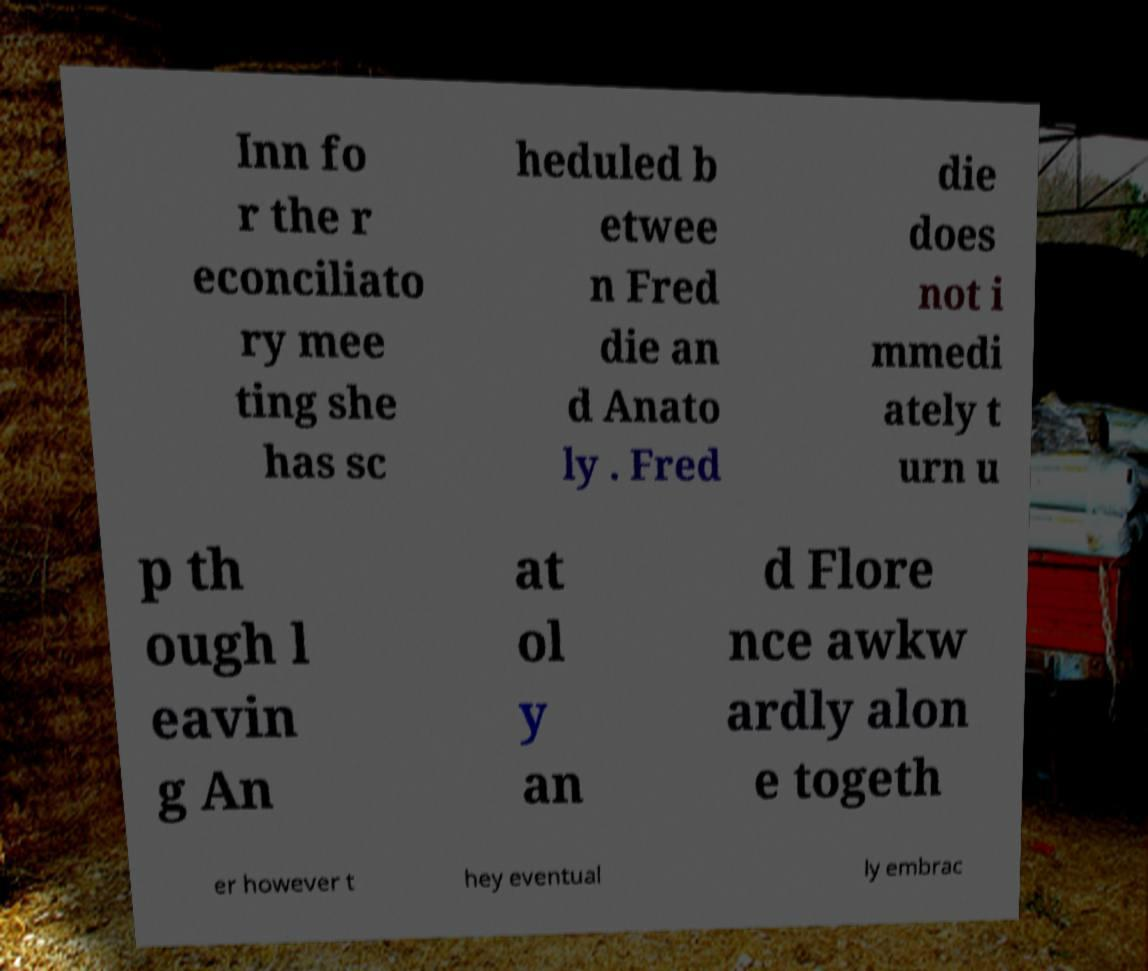Can you accurately transcribe the text from the provided image for me? Inn fo r the r econciliato ry mee ting she has sc heduled b etwee n Fred die an d Anato ly . Fred die does not i mmedi ately t urn u p th ough l eavin g An at ol y an d Flore nce awkw ardly alon e togeth er however t hey eventual ly embrac 